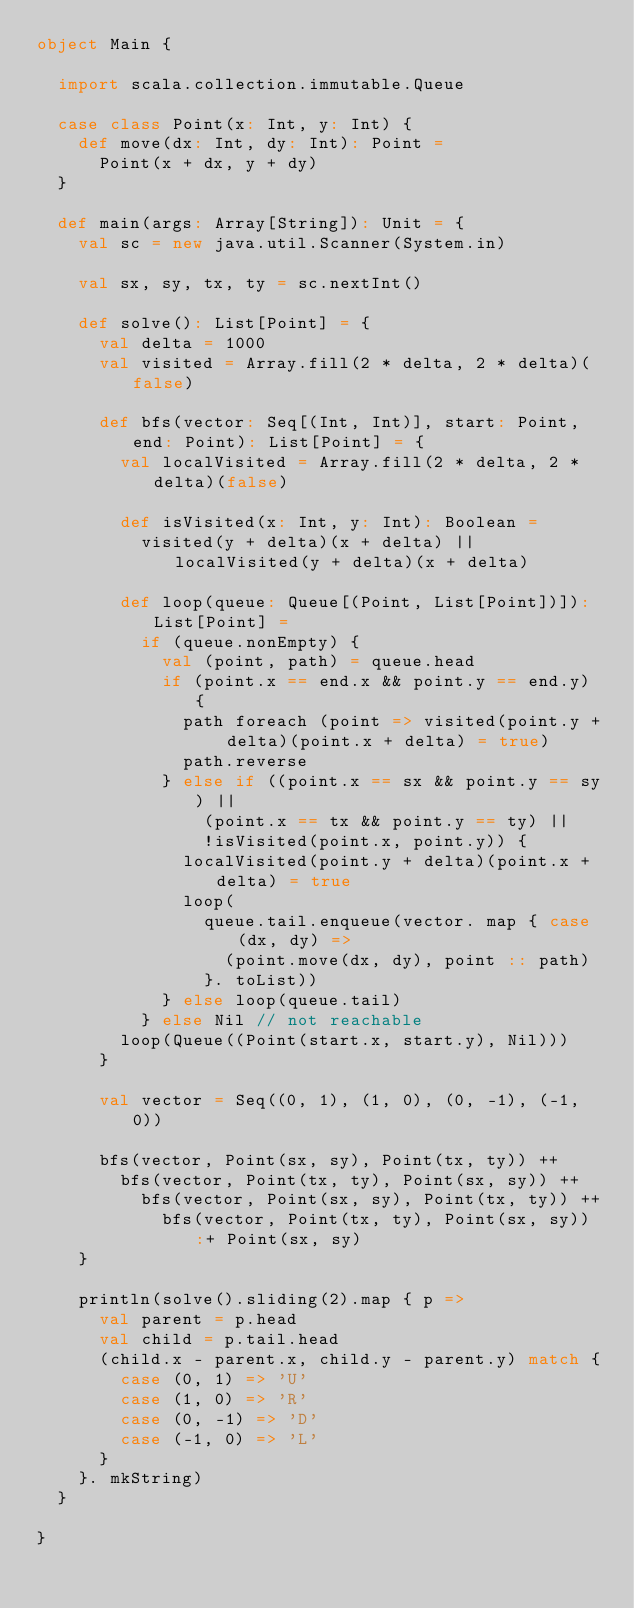Convert code to text. <code><loc_0><loc_0><loc_500><loc_500><_Scala_>object Main {

  import scala.collection.immutable.Queue

  case class Point(x: Int, y: Int) {
    def move(dx: Int, dy: Int): Point =
      Point(x + dx, y + dy)
  }

  def main(args: Array[String]): Unit = {
    val sc = new java.util.Scanner(System.in)

    val sx, sy, tx, ty = sc.nextInt()

    def solve(): List[Point] = {
      val delta = 1000
      val visited = Array.fill(2 * delta, 2 * delta)(false)

      def bfs(vector: Seq[(Int, Int)], start: Point, end: Point): List[Point] = {
        val localVisited = Array.fill(2 * delta, 2 * delta)(false)

        def isVisited(x: Int, y: Int): Boolean =
          visited(y + delta)(x + delta) || localVisited(y + delta)(x + delta)

        def loop(queue: Queue[(Point, List[Point])]): List[Point] =
          if (queue.nonEmpty) {
            val (point, path) = queue.head
            if (point.x == end.x && point.y == end.y) {
              path foreach (point => visited(point.y + delta)(point.x + delta) = true)
              path.reverse
            } else if ((point.x == sx && point.y == sy) ||
                (point.x == tx && point.y == ty) ||
                !isVisited(point.x, point.y)) {
              localVisited(point.y + delta)(point.x + delta) = true
              loop(
                queue.tail.enqueue(vector. map { case (dx, dy) =>
                  (point.move(dx, dy), point :: path)
                }. toList))
            } else loop(queue.tail)
          } else Nil // not reachable
        loop(Queue((Point(start.x, start.y), Nil)))
      }

      val vector = Seq((0, 1), (1, 0), (0, -1), (-1, 0))

      bfs(vector, Point(sx, sy), Point(tx, ty)) ++
        bfs(vector, Point(tx, ty), Point(sx, sy)) ++
          bfs(vector, Point(sx, sy), Point(tx, ty)) ++
            bfs(vector, Point(tx, ty), Point(sx, sy)) :+ Point(sx, sy)
    }

    println(solve().sliding(2).map { p =>
      val parent = p.head
      val child = p.tail.head
      (child.x - parent.x, child.y - parent.y) match {
        case (0, 1) => 'U'
        case (1, 0) => 'R'
        case (0, -1) => 'D'
        case (-1, 0) => 'L'
      }
    }. mkString)
  }

}
</code> 